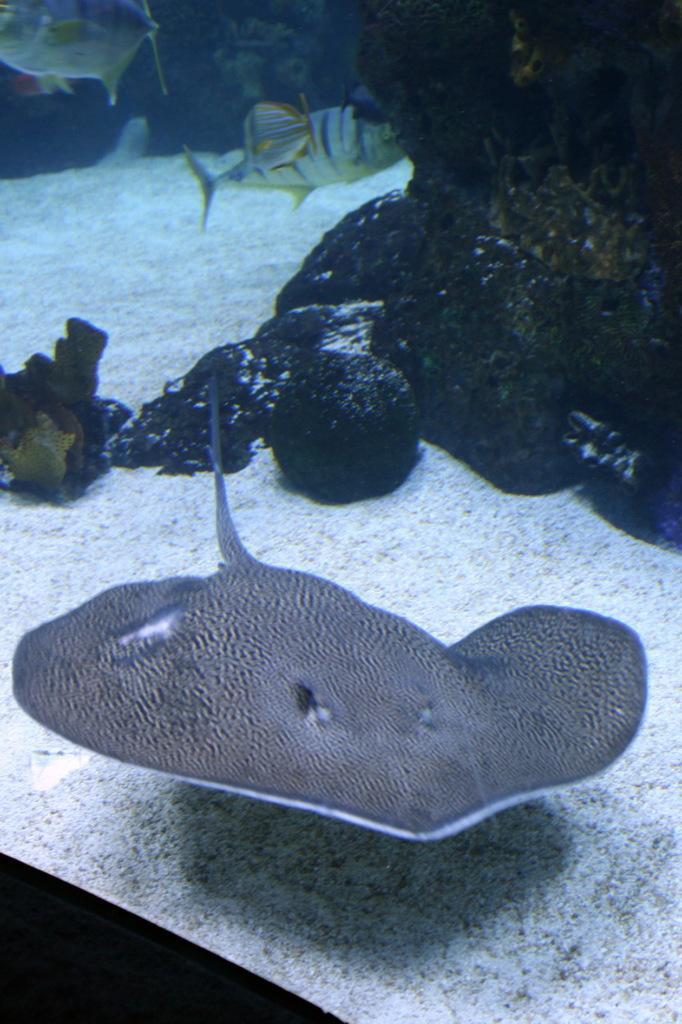How would you summarize this image in a sentence or two? There are two fishes in the water as we can see at the top of this image, and one fish is at the bottom of this image. There are some rocks in the water as we can see in the middle of this image. 